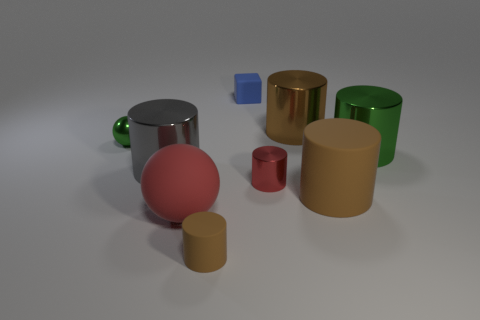What material is the big red object?
Keep it short and to the point. Rubber. There is a big thing that is the same shape as the small green metal thing; what is it made of?
Provide a short and direct response. Rubber. Do the tiny red thing and the big brown cylinder in front of the green ball have the same material?
Provide a succinct answer. No. What number of other rubber objects are the same shape as the tiny blue thing?
Give a very brief answer. 0. Are there more gray metal cylinders on the right side of the red matte ball than small red things on the left side of the small green ball?
Offer a terse response. No. Does the large matte cylinder have the same color as the large metallic thing left of the brown shiny thing?
Your answer should be very brief. No. What is the material of the gray object that is the same size as the brown metal object?
Provide a succinct answer. Metal. How many things are either big brown things or brown metal cylinders in front of the tiny blue rubber cube?
Your answer should be very brief. 2. There is a red metal cylinder; does it have the same size as the ball that is in front of the small green sphere?
Provide a short and direct response. No. What number of cylinders are either small metal things or small purple metal things?
Make the answer very short. 1. 